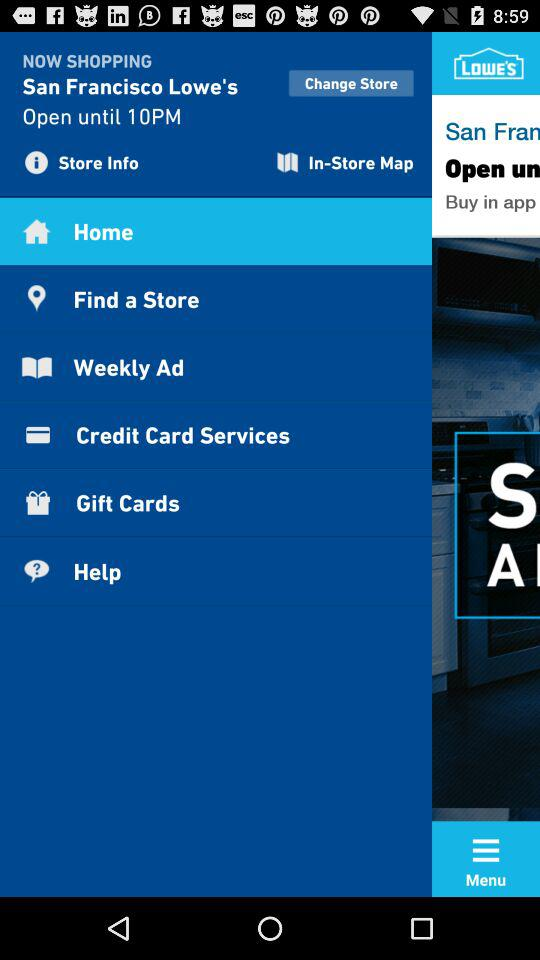Which item is selected? The item "Home" is selected. 